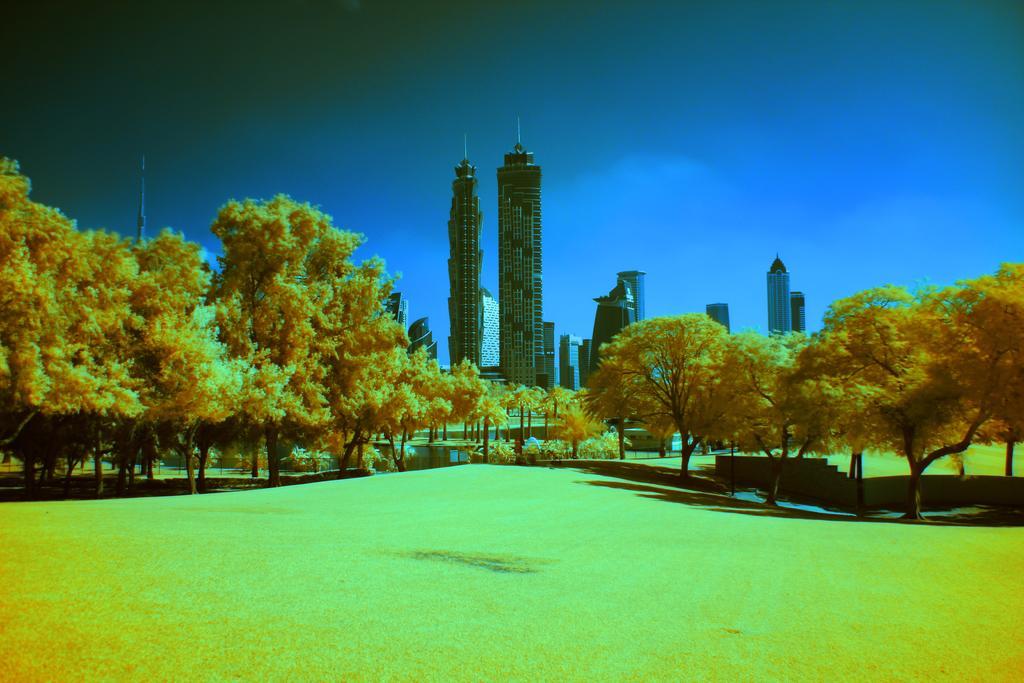Could you give a brief overview of what you see in this image? This image is taken outdoors. At the top of the image there is the sky with clouds. At the bottom of the image there is a ground with grass on it. In the background there are many buildings and skyscrapers. In the middle of the image there are many trees and plants with leaves, stems and branches. This image is an edited image. 